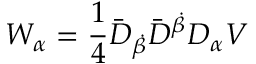Convert formula to latex. <formula><loc_0><loc_0><loc_500><loc_500>W _ { \alpha } = \frac { 1 } { 4 } \bar { D } _ { \dot { \beta } } \bar { D } ^ { \dot { \beta } } D _ { \alpha } V</formula> 